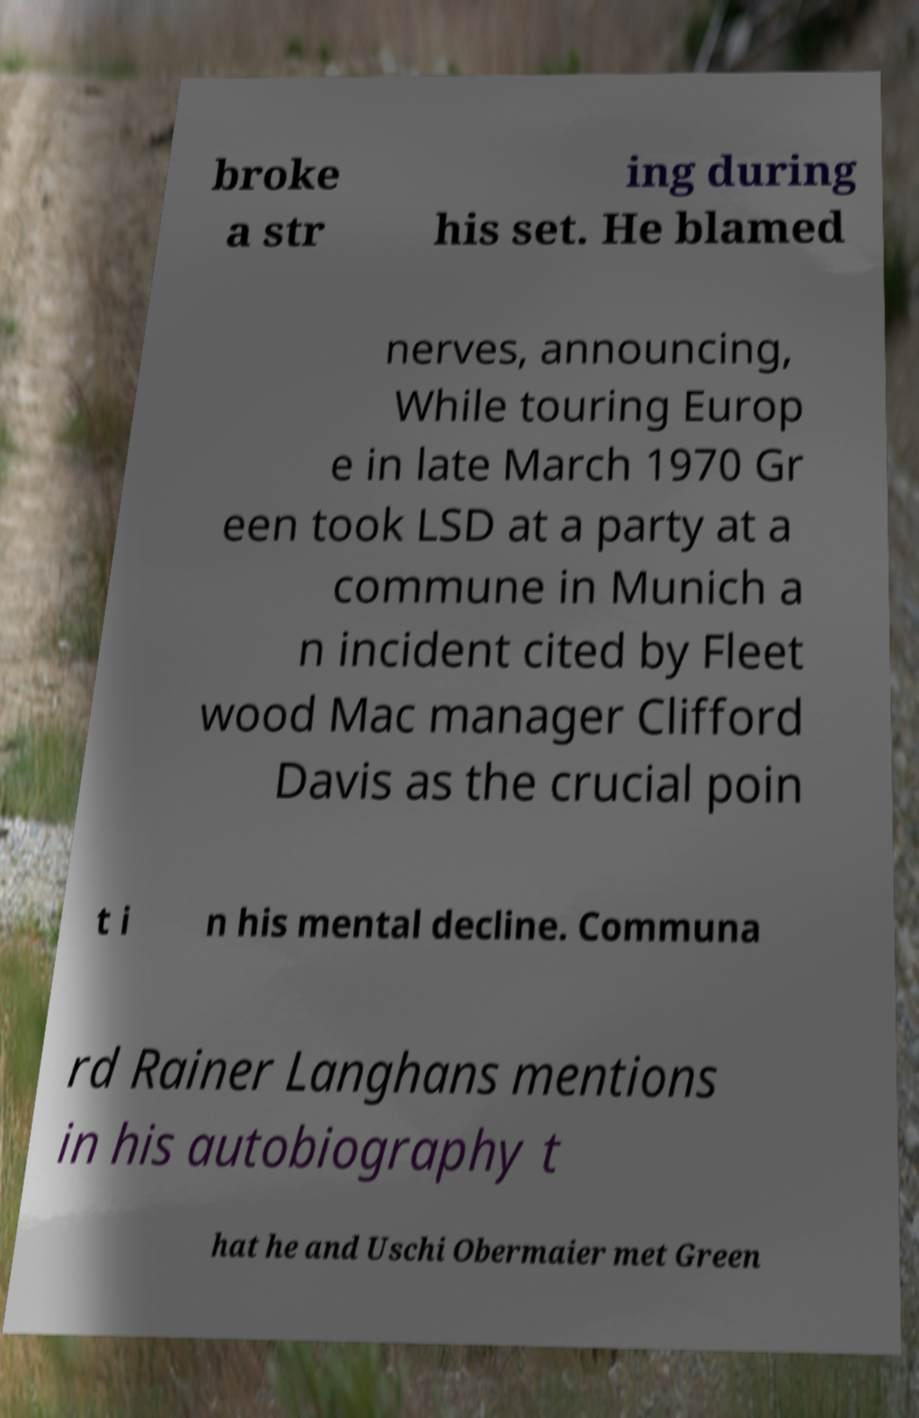Can you read and provide the text displayed in the image?This photo seems to have some interesting text. Can you extract and type it out for me? broke a str ing during his set. He blamed nerves, announcing, While touring Europ e in late March 1970 Gr een took LSD at a party at a commune in Munich a n incident cited by Fleet wood Mac manager Clifford Davis as the crucial poin t i n his mental decline. Communa rd Rainer Langhans mentions in his autobiography t hat he and Uschi Obermaier met Green 